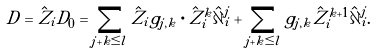<formula> <loc_0><loc_0><loc_500><loc_500>D = \hat { Z } _ { i } D _ { 0 } = \sum _ { j + k \leq l } \hat { Z } _ { i } g _ { j , k } \cdot \hat { Z } _ { i } ^ { k } \hat { \partial } _ { i } ^ { j } + \sum _ { j + k \leq l } g _ { j , k } \hat { Z } _ { i } ^ { k + 1 } \hat { \partial } _ { i } ^ { j } .</formula> 